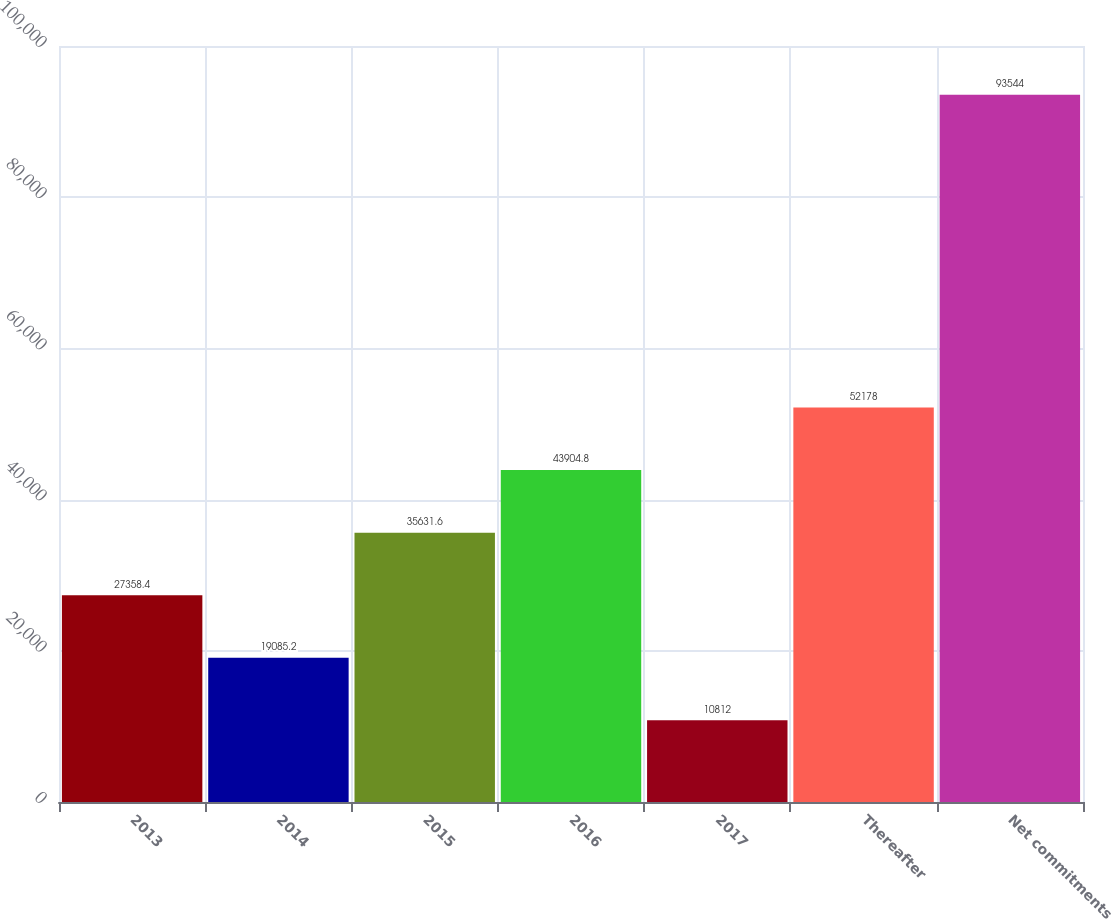<chart> <loc_0><loc_0><loc_500><loc_500><bar_chart><fcel>2013<fcel>2014<fcel>2015<fcel>2016<fcel>2017<fcel>Thereafter<fcel>Net commitments<nl><fcel>27358.4<fcel>19085.2<fcel>35631.6<fcel>43904.8<fcel>10812<fcel>52178<fcel>93544<nl></chart> 